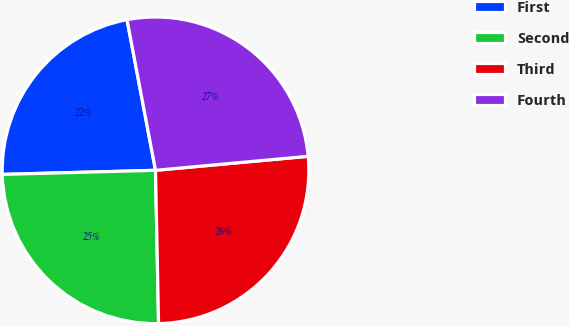<chart> <loc_0><loc_0><loc_500><loc_500><pie_chart><fcel>First<fcel>Second<fcel>Third<fcel>Fourth<nl><fcel>22.45%<fcel>24.89%<fcel>26.14%<fcel>26.52%<nl></chart> 